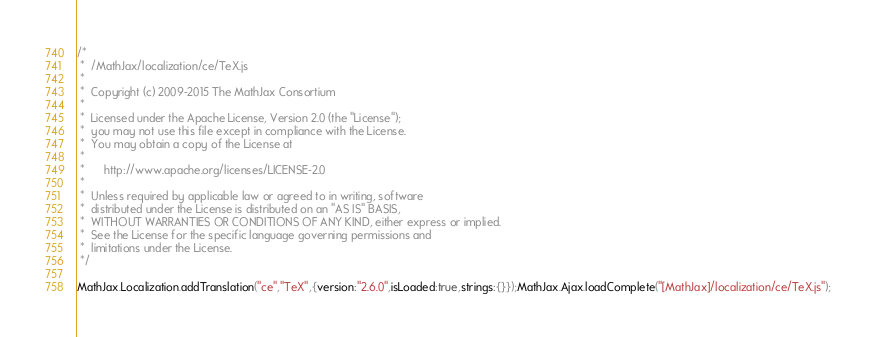<code> <loc_0><loc_0><loc_500><loc_500><_JavaScript_>/*
 *  /MathJax/localization/ce/TeX.js
 *
 *  Copyright (c) 2009-2015 The MathJax Consortium
 *
 *  Licensed under the Apache License, Version 2.0 (the "License");
 *  you may not use this file except in compliance with the License.
 *  You may obtain a copy of the License at
 *
 *      http://www.apache.org/licenses/LICENSE-2.0
 *
 *  Unless required by applicable law or agreed to in writing, software
 *  distributed under the License is distributed on an "AS IS" BASIS,
 *  WITHOUT WARRANTIES OR CONDITIONS OF ANY KIND, either express or implied.
 *  See the License for the specific language governing permissions and
 *  limitations under the License.
 */

MathJax.Localization.addTranslation("ce","TeX",{version:"2.6.0",isLoaded:true,strings:{}});MathJax.Ajax.loadComplete("[MathJax]/localization/ce/TeX.js");
</code> 